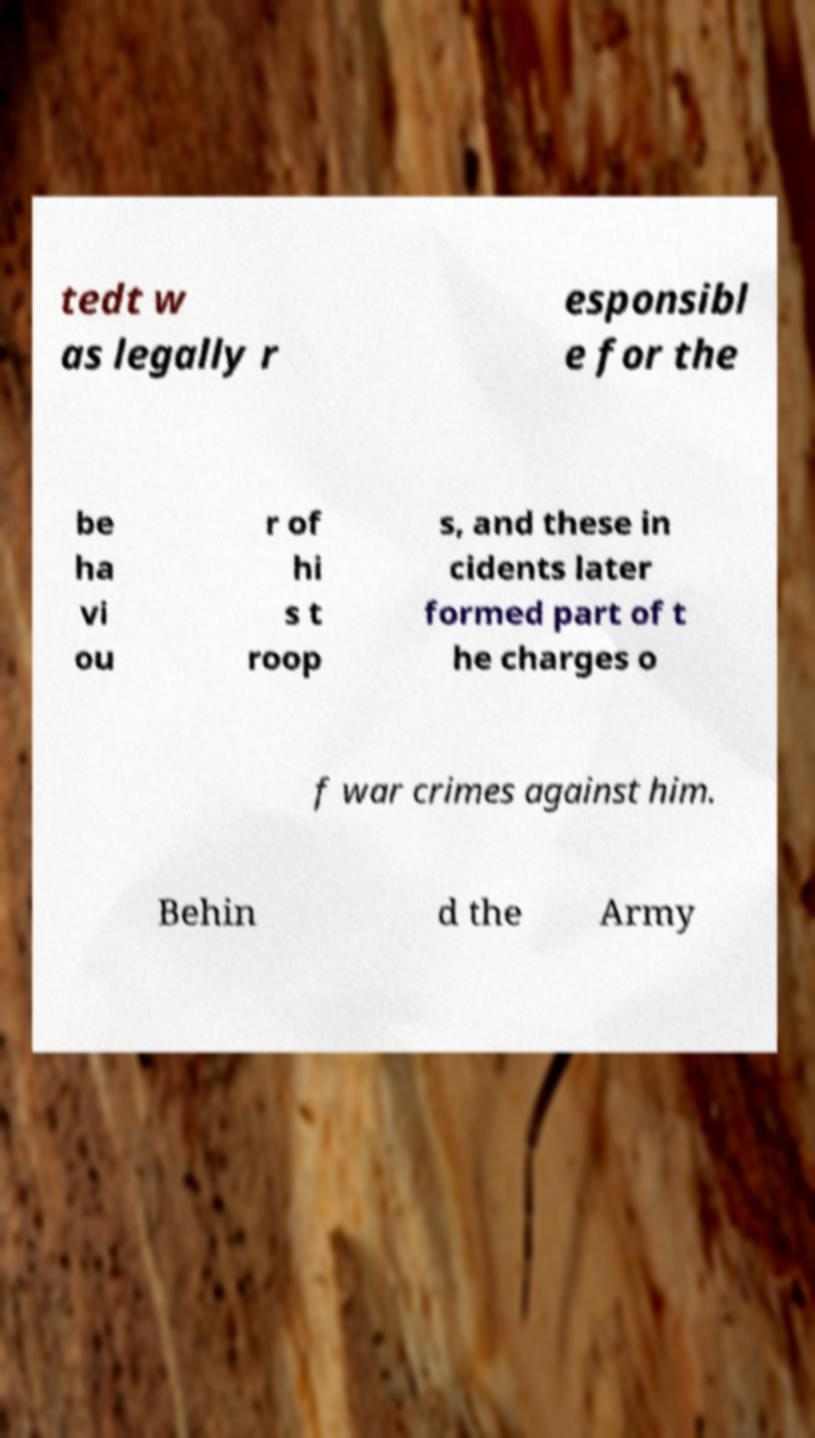For documentation purposes, I need the text within this image transcribed. Could you provide that? tedt w as legally r esponsibl e for the be ha vi ou r of hi s t roop s, and these in cidents later formed part of t he charges o f war crimes against him. Behin d the Army 